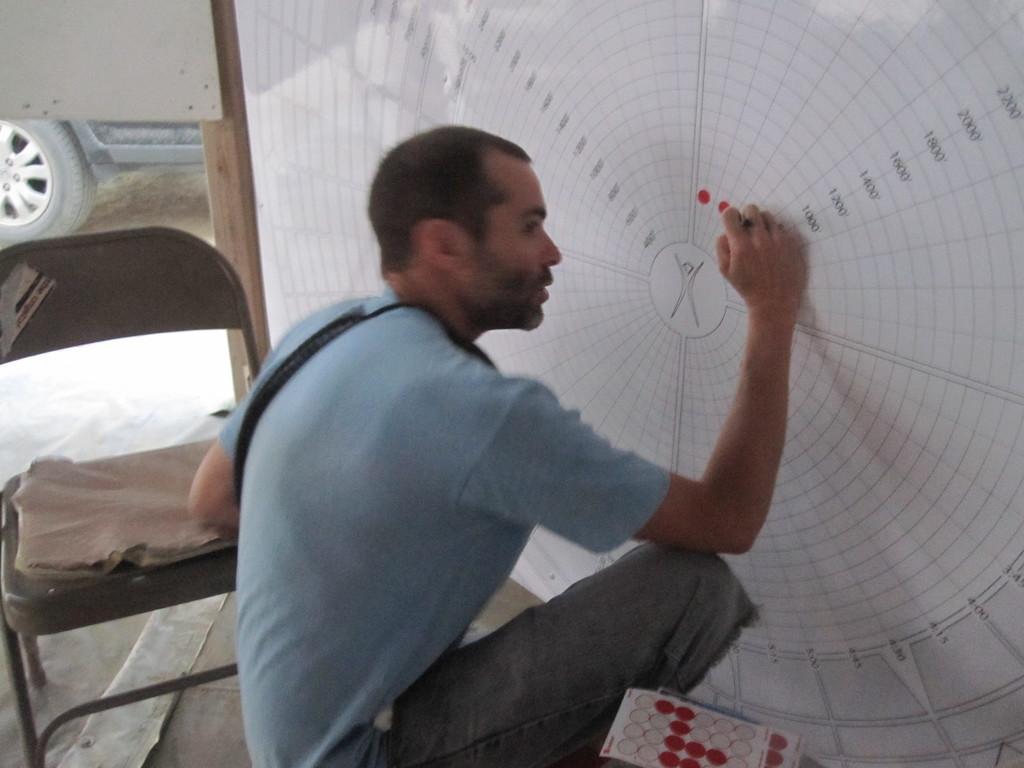How would you summarize this image in a sentence or two? In this image I can see a man is sitting. In the background I can see a chair, a vehicle, a white color board and other objects. 